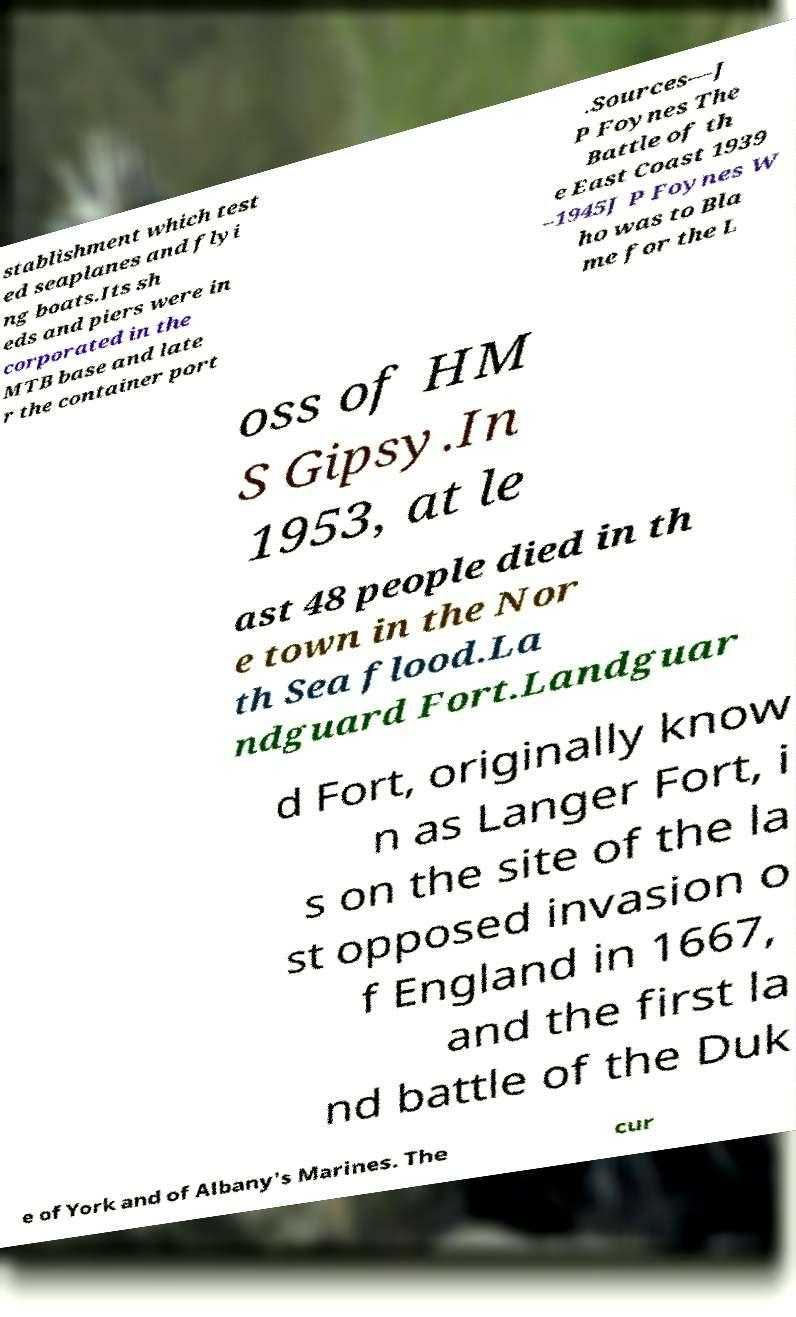For documentation purposes, I need the text within this image transcribed. Could you provide that? stablishment which test ed seaplanes and flyi ng boats.Its sh eds and piers were in corporated in the MTB base and late r the container port .Sources—J P Foynes The Battle of th e East Coast 1939 –1945J P Foynes W ho was to Bla me for the L oss of HM S Gipsy.In 1953, at le ast 48 people died in th e town in the Nor th Sea flood.La ndguard Fort.Landguar d Fort, originally know n as Langer Fort, i s on the site of the la st opposed invasion o f England in 1667, and the first la nd battle of the Duk e of York and of Albany's Marines. The cur 